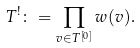Convert formula to latex. <formula><loc_0><loc_0><loc_500><loc_500>T ^ { ! } \colon = \prod _ { v \in T ^ { [ 0 ] } } w ( v ) .</formula> 